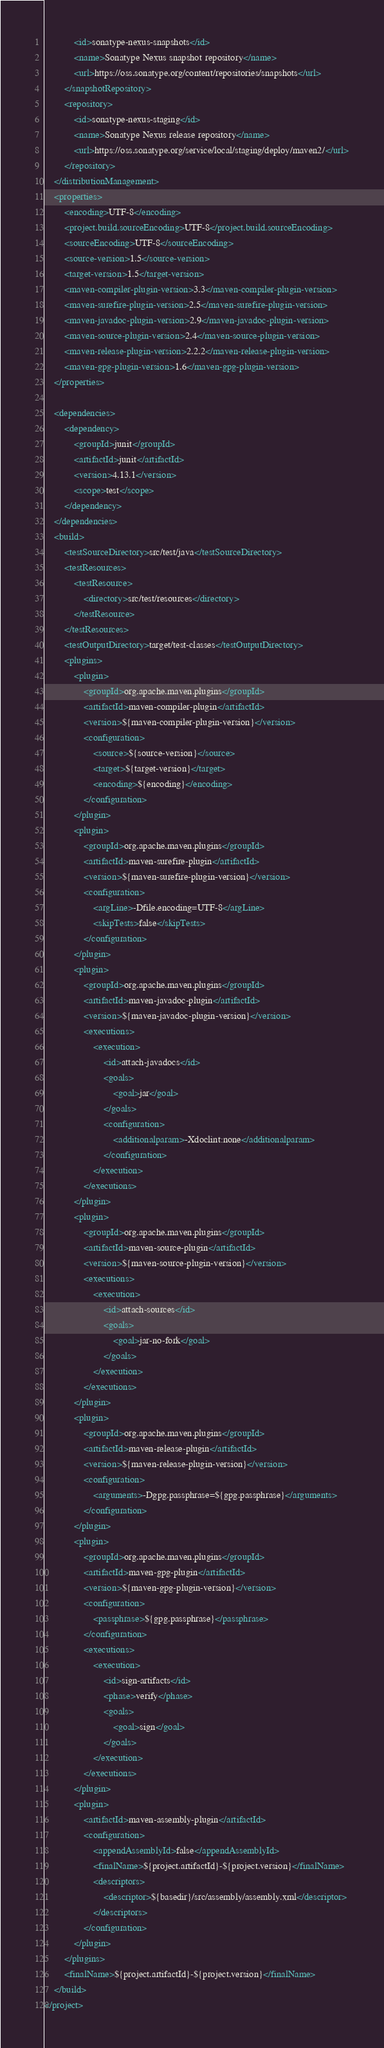Convert code to text. <code><loc_0><loc_0><loc_500><loc_500><_XML_>            <id>sonatype-nexus-snapshots</id>
            <name>Sonatype Nexus snapshot repository</name>
            <url>https://oss.sonatype.org/content/repositories/snapshots</url>
        </snapshotRepository>
        <repository>
            <id>sonatype-nexus-staging</id>
            <name>Sonatype Nexus release repository</name>
            <url>https://oss.sonatype.org/service/local/staging/deploy/maven2/</url>
        </repository>
    </distributionManagement>
    <properties>
        <encoding>UTF-8</encoding>
        <project.build.sourceEncoding>UTF-8</project.build.sourceEncoding>
        <sourceEncoding>UTF-8</sourceEncoding>
        <source-version>1.5</source-version>
        <target-version>1.5</target-version>
        <maven-compiler-plugin-version>3.3</maven-compiler-plugin-version>
        <maven-surefire-plugin-version>2.5</maven-surefire-plugin-version>
        <maven-javadoc-plugin-version>2.9</maven-javadoc-plugin-version>
        <maven-source-plugin-version>2.4</maven-source-plugin-version>
        <maven-release-plugin-version>2.2.2</maven-release-plugin-version>
        <maven-gpg-plugin-version>1.6</maven-gpg-plugin-version>
    </properties>

    <dependencies>
        <dependency>
            <groupId>junit</groupId>
            <artifactId>junit</artifactId>
            <version>4.13.1</version>
            <scope>test</scope>
        </dependency>
    </dependencies>
    <build>
        <testSourceDirectory>src/test/java</testSourceDirectory>
        <testResources>
            <testResource>
                <directory>src/test/resources</directory>
            </testResource>
        </testResources>
        <testOutputDirectory>target/test-classes</testOutputDirectory>
        <plugins>
            <plugin>
                <groupId>org.apache.maven.plugins</groupId>
                <artifactId>maven-compiler-plugin</artifactId>
                <version>${maven-compiler-plugin-version}</version>
                <configuration>
                    <source>${source-version}</source>
                    <target>${target-version}</target>
                    <encoding>${encoding}</encoding>
                </configuration>
            </plugin>
            <plugin>
                <groupId>org.apache.maven.plugins</groupId>
                <artifactId>maven-surefire-plugin</artifactId>
                <version>${maven-surefire-plugin-version}</version>
                <configuration>
                    <argLine>-Dfile.encoding=UTF-8</argLine>
                    <skipTests>false</skipTests>
                </configuration>
            </plugin>
            <plugin>
                <groupId>org.apache.maven.plugins</groupId>
                <artifactId>maven-javadoc-plugin</artifactId>
                <version>${maven-javadoc-plugin-version}</version>
                <executions>
                    <execution>
                        <id>attach-javadocs</id>
                        <goals>
                            <goal>jar</goal>
                        </goals>
                        <configuration>
                            <additionalparam>-Xdoclint:none</additionalparam>
                        </configuration>
                    </execution>
                </executions>
            </plugin>
            <plugin>
                <groupId>org.apache.maven.plugins</groupId>
                <artifactId>maven-source-plugin</artifactId>
                <version>${maven-source-plugin-version}</version>
                <executions>
                    <execution>
                        <id>attach-sources</id>
                        <goals>
                            <goal>jar-no-fork</goal>
                        </goals>
                    </execution>
                </executions>
            </plugin>
            <plugin>
                <groupId>org.apache.maven.plugins</groupId>
                <artifactId>maven-release-plugin</artifactId>
                <version>${maven-release-plugin-version}</version>
                <configuration>
                    <arguments>-Dgpg.passphrase=${gpg.passphrase}</arguments>
                </configuration>
            </plugin>
            <plugin>
                <groupId>org.apache.maven.plugins</groupId>
                <artifactId>maven-gpg-plugin</artifactId>
                <version>${maven-gpg-plugin-version}</version>
                <configuration>
                    <passphrase>${gpg.passphrase}</passphrase>
                </configuration>
                <executions>
                    <execution>
                        <id>sign-artifacts</id>
                        <phase>verify</phase>
                        <goals>
                            <goal>sign</goal>
                        </goals>
                    </execution>
                </executions>
            </plugin>
            <plugin>
                <artifactId>maven-assembly-plugin</artifactId>
                <configuration>
                    <appendAssemblyId>false</appendAssemblyId>
                    <finalName>${project.artifactId}-${project.version}</finalName>
                    <descriptors>
                        <descriptor>${basedir}/src/assembly/assembly.xml</descriptor>
                    </descriptors>
                </configuration>
            </plugin>
        </plugins>
        <finalName>${project.artifactId}-${project.version}</finalName>
    </build>
</project>
</code> 